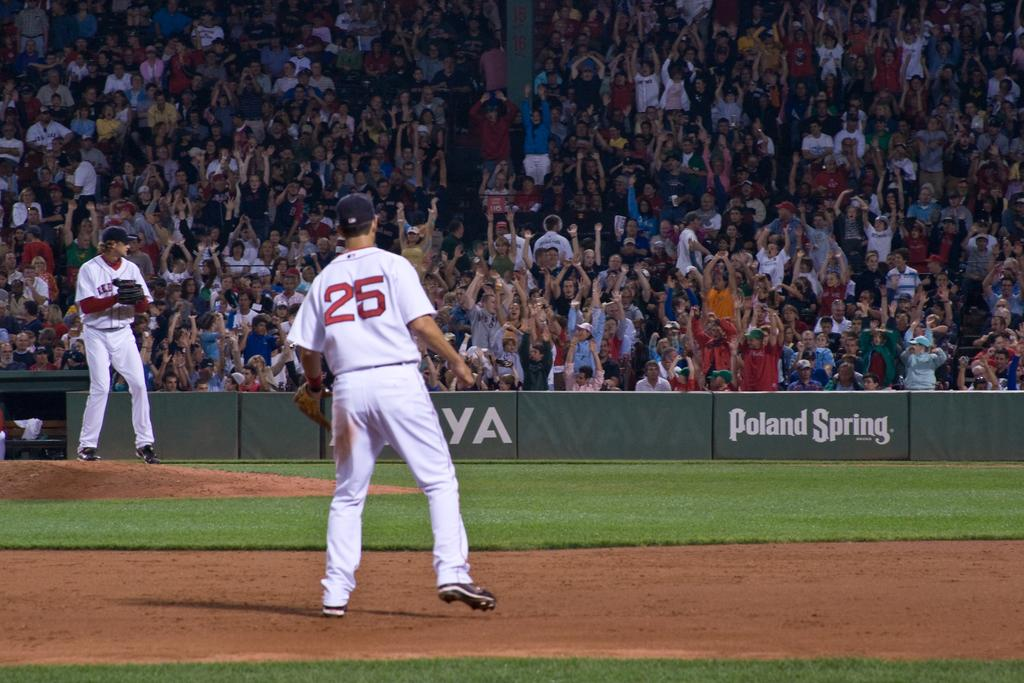<image>
Provide a brief description of the given image. A baseball player number 25 stands on the field in front of a crowd and a Poland Spring sign. 